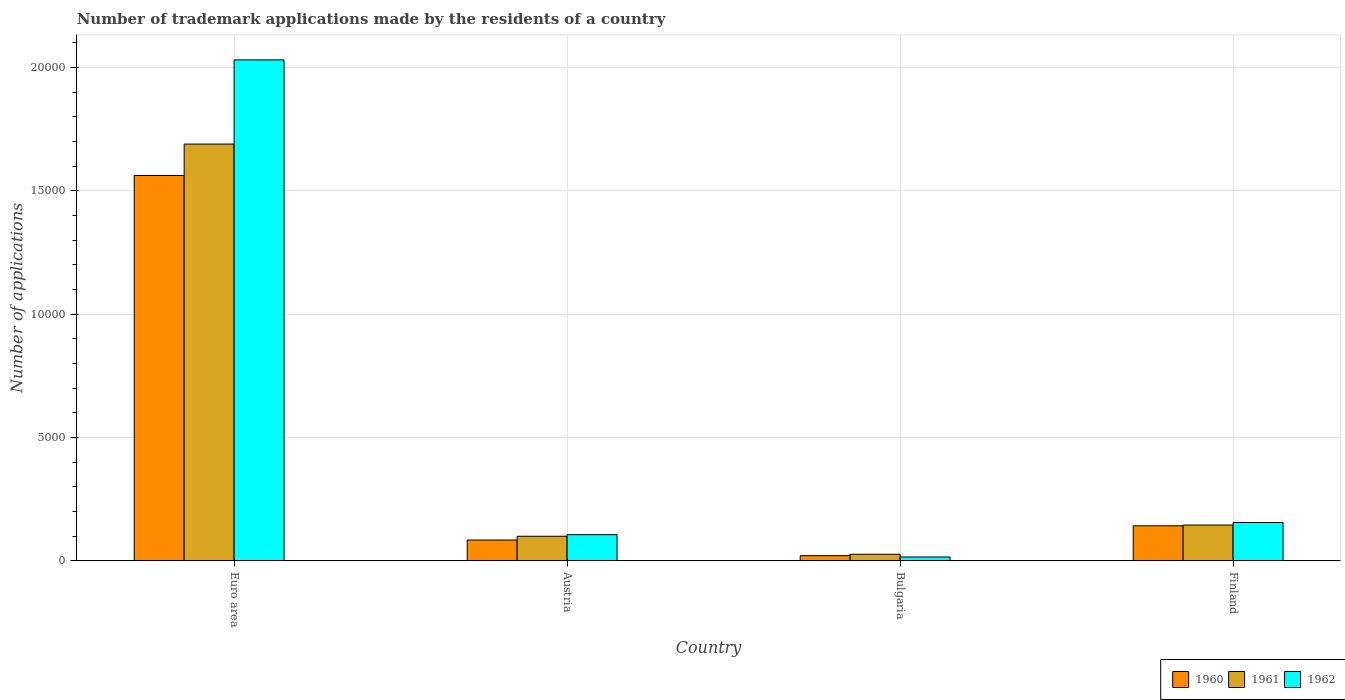How many different coloured bars are there?
Provide a short and direct response. 3. How many groups of bars are there?
Make the answer very short. 4. Are the number of bars on each tick of the X-axis equal?
Ensure brevity in your answer.  Yes. How many bars are there on the 3rd tick from the left?
Make the answer very short. 3. What is the label of the 4th group of bars from the left?
Offer a very short reply. Finland. What is the number of trademark applications made by the residents in 1962 in Bulgaria?
Your answer should be very brief. 157. Across all countries, what is the maximum number of trademark applications made by the residents in 1961?
Ensure brevity in your answer.  1.69e+04. Across all countries, what is the minimum number of trademark applications made by the residents in 1962?
Your response must be concise. 157. In which country was the number of trademark applications made by the residents in 1962 maximum?
Keep it short and to the point. Euro area. In which country was the number of trademark applications made by the residents in 1962 minimum?
Your response must be concise. Bulgaria. What is the total number of trademark applications made by the residents in 1962 in the graph?
Provide a short and direct response. 2.31e+04. What is the difference between the number of trademark applications made by the residents in 1961 in Bulgaria and that in Finland?
Your answer should be very brief. -1185. What is the difference between the number of trademark applications made by the residents in 1960 in Austria and the number of trademark applications made by the residents in 1962 in Finland?
Your answer should be compact. -710. What is the average number of trademark applications made by the residents in 1960 per country?
Keep it short and to the point. 4525.5. What is the difference between the number of trademark applications made by the residents of/in 1960 and number of trademark applications made by the residents of/in 1961 in Euro area?
Keep it short and to the point. -1274. In how many countries, is the number of trademark applications made by the residents in 1960 greater than 3000?
Your answer should be compact. 1. What is the ratio of the number of trademark applications made by the residents in 1961 in Austria to that in Bulgaria?
Provide a short and direct response. 3.73. Is the number of trademark applications made by the residents in 1960 in Austria less than that in Finland?
Your response must be concise. Yes. What is the difference between the highest and the second highest number of trademark applications made by the residents in 1961?
Keep it short and to the point. 1.54e+04. What is the difference between the highest and the lowest number of trademark applications made by the residents in 1961?
Offer a very short reply. 1.66e+04. What does the 2nd bar from the right in Bulgaria represents?
Give a very brief answer. 1961. How many bars are there?
Ensure brevity in your answer.  12. What is the difference between two consecutive major ticks on the Y-axis?
Offer a terse response. 5000. How many legend labels are there?
Provide a succinct answer. 3. How are the legend labels stacked?
Your response must be concise. Horizontal. What is the title of the graph?
Ensure brevity in your answer.  Number of trademark applications made by the residents of a country. What is the label or title of the X-axis?
Provide a succinct answer. Country. What is the label or title of the Y-axis?
Offer a very short reply. Number of applications. What is the Number of applications in 1960 in Euro area?
Provide a succinct answer. 1.56e+04. What is the Number of applications of 1961 in Euro area?
Provide a short and direct response. 1.69e+04. What is the Number of applications in 1962 in Euro area?
Your answer should be compact. 2.03e+04. What is the Number of applications in 1960 in Austria?
Provide a short and direct response. 845. What is the Number of applications of 1961 in Austria?
Your response must be concise. 997. What is the Number of applications of 1962 in Austria?
Keep it short and to the point. 1061. What is the Number of applications in 1960 in Bulgaria?
Your response must be concise. 211. What is the Number of applications in 1961 in Bulgaria?
Ensure brevity in your answer.  267. What is the Number of applications of 1962 in Bulgaria?
Provide a short and direct response. 157. What is the Number of applications of 1960 in Finland?
Offer a terse response. 1421. What is the Number of applications in 1961 in Finland?
Keep it short and to the point. 1452. What is the Number of applications of 1962 in Finland?
Make the answer very short. 1555. Across all countries, what is the maximum Number of applications in 1960?
Your response must be concise. 1.56e+04. Across all countries, what is the maximum Number of applications of 1961?
Offer a very short reply. 1.69e+04. Across all countries, what is the maximum Number of applications in 1962?
Your answer should be compact. 2.03e+04. Across all countries, what is the minimum Number of applications in 1960?
Ensure brevity in your answer.  211. Across all countries, what is the minimum Number of applications in 1961?
Offer a terse response. 267. Across all countries, what is the minimum Number of applications in 1962?
Provide a short and direct response. 157. What is the total Number of applications in 1960 in the graph?
Keep it short and to the point. 1.81e+04. What is the total Number of applications of 1961 in the graph?
Give a very brief answer. 1.96e+04. What is the total Number of applications in 1962 in the graph?
Your answer should be very brief. 2.31e+04. What is the difference between the Number of applications of 1960 in Euro area and that in Austria?
Ensure brevity in your answer.  1.48e+04. What is the difference between the Number of applications of 1961 in Euro area and that in Austria?
Offer a terse response. 1.59e+04. What is the difference between the Number of applications of 1962 in Euro area and that in Austria?
Offer a terse response. 1.92e+04. What is the difference between the Number of applications of 1960 in Euro area and that in Bulgaria?
Keep it short and to the point. 1.54e+04. What is the difference between the Number of applications in 1961 in Euro area and that in Bulgaria?
Provide a short and direct response. 1.66e+04. What is the difference between the Number of applications of 1962 in Euro area and that in Bulgaria?
Give a very brief answer. 2.02e+04. What is the difference between the Number of applications in 1960 in Euro area and that in Finland?
Your response must be concise. 1.42e+04. What is the difference between the Number of applications in 1961 in Euro area and that in Finland?
Ensure brevity in your answer.  1.54e+04. What is the difference between the Number of applications of 1962 in Euro area and that in Finland?
Your answer should be very brief. 1.88e+04. What is the difference between the Number of applications of 1960 in Austria and that in Bulgaria?
Keep it short and to the point. 634. What is the difference between the Number of applications in 1961 in Austria and that in Bulgaria?
Keep it short and to the point. 730. What is the difference between the Number of applications of 1962 in Austria and that in Bulgaria?
Provide a succinct answer. 904. What is the difference between the Number of applications in 1960 in Austria and that in Finland?
Provide a short and direct response. -576. What is the difference between the Number of applications of 1961 in Austria and that in Finland?
Your response must be concise. -455. What is the difference between the Number of applications of 1962 in Austria and that in Finland?
Make the answer very short. -494. What is the difference between the Number of applications of 1960 in Bulgaria and that in Finland?
Give a very brief answer. -1210. What is the difference between the Number of applications of 1961 in Bulgaria and that in Finland?
Provide a short and direct response. -1185. What is the difference between the Number of applications in 1962 in Bulgaria and that in Finland?
Your answer should be very brief. -1398. What is the difference between the Number of applications of 1960 in Euro area and the Number of applications of 1961 in Austria?
Offer a terse response. 1.46e+04. What is the difference between the Number of applications of 1960 in Euro area and the Number of applications of 1962 in Austria?
Your answer should be compact. 1.46e+04. What is the difference between the Number of applications in 1961 in Euro area and the Number of applications in 1962 in Austria?
Your answer should be very brief. 1.58e+04. What is the difference between the Number of applications of 1960 in Euro area and the Number of applications of 1961 in Bulgaria?
Your answer should be very brief. 1.54e+04. What is the difference between the Number of applications in 1960 in Euro area and the Number of applications in 1962 in Bulgaria?
Keep it short and to the point. 1.55e+04. What is the difference between the Number of applications in 1961 in Euro area and the Number of applications in 1962 in Bulgaria?
Offer a terse response. 1.67e+04. What is the difference between the Number of applications of 1960 in Euro area and the Number of applications of 1961 in Finland?
Ensure brevity in your answer.  1.42e+04. What is the difference between the Number of applications of 1960 in Euro area and the Number of applications of 1962 in Finland?
Your answer should be very brief. 1.41e+04. What is the difference between the Number of applications in 1961 in Euro area and the Number of applications in 1962 in Finland?
Keep it short and to the point. 1.53e+04. What is the difference between the Number of applications of 1960 in Austria and the Number of applications of 1961 in Bulgaria?
Keep it short and to the point. 578. What is the difference between the Number of applications in 1960 in Austria and the Number of applications in 1962 in Bulgaria?
Give a very brief answer. 688. What is the difference between the Number of applications in 1961 in Austria and the Number of applications in 1962 in Bulgaria?
Offer a terse response. 840. What is the difference between the Number of applications in 1960 in Austria and the Number of applications in 1961 in Finland?
Keep it short and to the point. -607. What is the difference between the Number of applications in 1960 in Austria and the Number of applications in 1962 in Finland?
Keep it short and to the point. -710. What is the difference between the Number of applications in 1961 in Austria and the Number of applications in 1962 in Finland?
Keep it short and to the point. -558. What is the difference between the Number of applications in 1960 in Bulgaria and the Number of applications in 1961 in Finland?
Your answer should be compact. -1241. What is the difference between the Number of applications of 1960 in Bulgaria and the Number of applications of 1962 in Finland?
Provide a succinct answer. -1344. What is the difference between the Number of applications in 1961 in Bulgaria and the Number of applications in 1962 in Finland?
Offer a very short reply. -1288. What is the average Number of applications in 1960 per country?
Ensure brevity in your answer.  4525.5. What is the average Number of applications of 1961 per country?
Your answer should be very brief. 4903.75. What is the average Number of applications in 1962 per country?
Offer a very short reply. 5771. What is the difference between the Number of applications in 1960 and Number of applications in 1961 in Euro area?
Make the answer very short. -1274. What is the difference between the Number of applications in 1960 and Number of applications in 1962 in Euro area?
Offer a terse response. -4686. What is the difference between the Number of applications in 1961 and Number of applications in 1962 in Euro area?
Offer a terse response. -3412. What is the difference between the Number of applications of 1960 and Number of applications of 1961 in Austria?
Your answer should be very brief. -152. What is the difference between the Number of applications of 1960 and Number of applications of 1962 in Austria?
Your response must be concise. -216. What is the difference between the Number of applications in 1961 and Number of applications in 1962 in Austria?
Make the answer very short. -64. What is the difference between the Number of applications in 1960 and Number of applications in 1961 in Bulgaria?
Give a very brief answer. -56. What is the difference between the Number of applications in 1960 and Number of applications in 1962 in Bulgaria?
Your answer should be compact. 54. What is the difference between the Number of applications in 1961 and Number of applications in 1962 in Bulgaria?
Provide a short and direct response. 110. What is the difference between the Number of applications of 1960 and Number of applications of 1961 in Finland?
Your answer should be very brief. -31. What is the difference between the Number of applications in 1960 and Number of applications in 1962 in Finland?
Provide a short and direct response. -134. What is the difference between the Number of applications in 1961 and Number of applications in 1962 in Finland?
Keep it short and to the point. -103. What is the ratio of the Number of applications in 1960 in Euro area to that in Austria?
Provide a succinct answer. 18.49. What is the ratio of the Number of applications of 1961 in Euro area to that in Austria?
Provide a short and direct response. 16.95. What is the ratio of the Number of applications in 1962 in Euro area to that in Austria?
Your response must be concise. 19.14. What is the ratio of the Number of applications in 1960 in Euro area to that in Bulgaria?
Keep it short and to the point. 74.05. What is the ratio of the Number of applications of 1961 in Euro area to that in Bulgaria?
Provide a succinct answer. 63.29. What is the ratio of the Number of applications of 1962 in Euro area to that in Bulgaria?
Your answer should be very brief. 129.37. What is the ratio of the Number of applications in 1960 in Euro area to that in Finland?
Offer a very short reply. 11. What is the ratio of the Number of applications in 1961 in Euro area to that in Finland?
Keep it short and to the point. 11.64. What is the ratio of the Number of applications of 1962 in Euro area to that in Finland?
Your response must be concise. 13.06. What is the ratio of the Number of applications of 1960 in Austria to that in Bulgaria?
Make the answer very short. 4. What is the ratio of the Number of applications in 1961 in Austria to that in Bulgaria?
Provide a short and direct response. 3.73. What is the ratio of the Number of applications of 1962 in Austria to that in Bulgaria?
Provide a succinct answer. 6.76. What is the ratio of the Number of applications in 1960 in Austria to that in Finland?
Ensure brevity in your answer.  0.59. What is the ratio of the Number of applications in 1961 in Austria to that in Finland?
Provide a short and direct response. 0.69. What is the ratio of the Number of applications in 1962 in Austria to that in Finland?
Give a very brief answer. 0.68. What is the ratio of the Number of applications in 1960 in Bulgaria to that in Finland?
Make the answer very short. 0.15. What is the ratio of the Number of applications in 1961 in Bulgaria to that in Finland?
Make the answer very short. 0.18. What is the ratio of the Number of applications in 1962 in Bulgaria to that in Finland?
Keep it short and to the point. 0.1. What is the difference between the highest and the second highest Number of applications in 1960?
Offer a very short reply. 1.42e+04. What is the difference between the highest and the second highest Number of applications of 1961?
Keep it short and to the point. 1.54e+04. What is the difference between the highest and the second highest Number of applications of 1962?
Ensure brevity in your answer.  1.88e+04. What is the difference between the highest and the lowest Number of applications in 1960?
Offer a terse response. 1.54e+04. What is the difference between the highest and the lowest Number of applications of 1961?
Provide a short and direct response. 1.66e+04. What is the difference between the highest and the lowest Number of applications of 1962?
Your answer should be compact. 2.02e+04. 